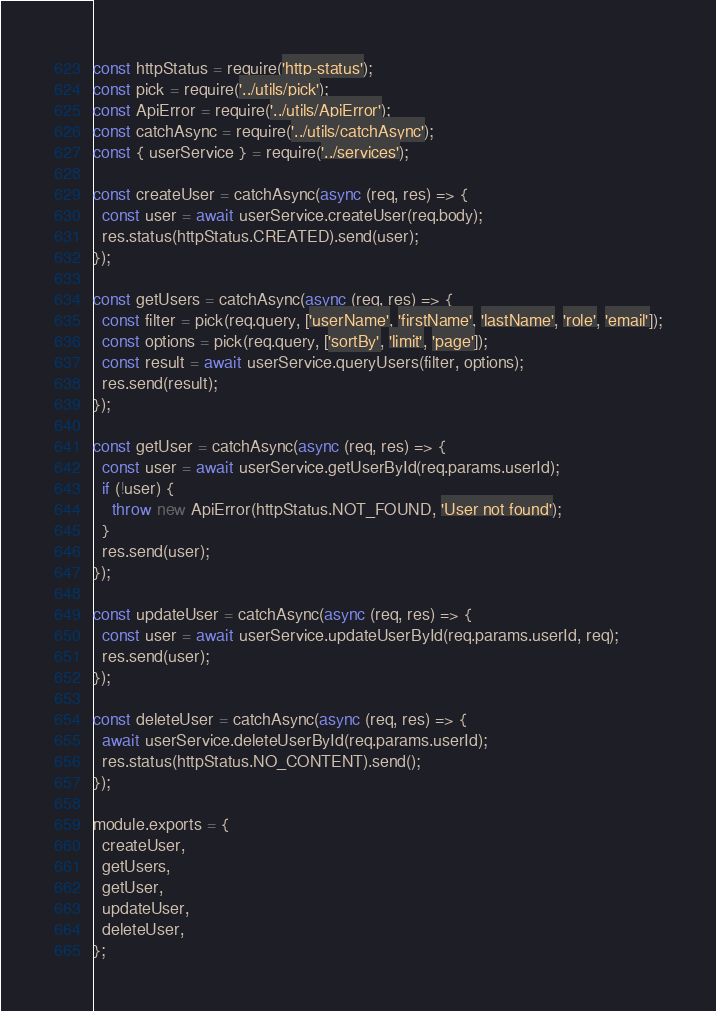<code> <loc_0><loc_0><loc_500><loc_500><_JavaScript_>const httpStatus = require('http-status');
const pick = require('../utils/pick');
const ApiError = require('../utils/ApiError');
const catchAsync = require('../utils/catchAsync');
const { userService } = require('../services');

const createUser = catchAsync(async (req, res) => {
  const user = await userService.createUser(req.body);
  res.status(httpStatus.CREATED).send(user);
});

const getUsers = catchAsync(async (req, res) => {
  const filter = pick(req.query, ['userName', 'firstName', 'lastName', 'role', 'email']);
  const options = pick(req.query, ['sortBy', 'limit', 'page']);
  const result = await userService.queryUsers(filter, options);
  res.send(result);
});

const getUser = catchAsync(async (req, res) => {
  const user = await userService.getUserById(req.params.userId);
  if (!user) {
    throw new ApiError(httpStatus.NOT_FOUND, 'User not found');
  }
  res.send(user);
});

const updateUser = catchAsync(async (req, res) => {
  const user = await userService.updateUserById(req.params.userId, req);
  res.send(user);
});

const deleteUser = catchAsync(async (req, res) => {
  await userService.deleteUserById(req.params.userId);
  res.status(httpStatus.NO_CONTENT).send();
});

module.exports = {
  createUser,
  getUsers,
  getUser,
  updateUser,
  deleteUser,
};
</code> 